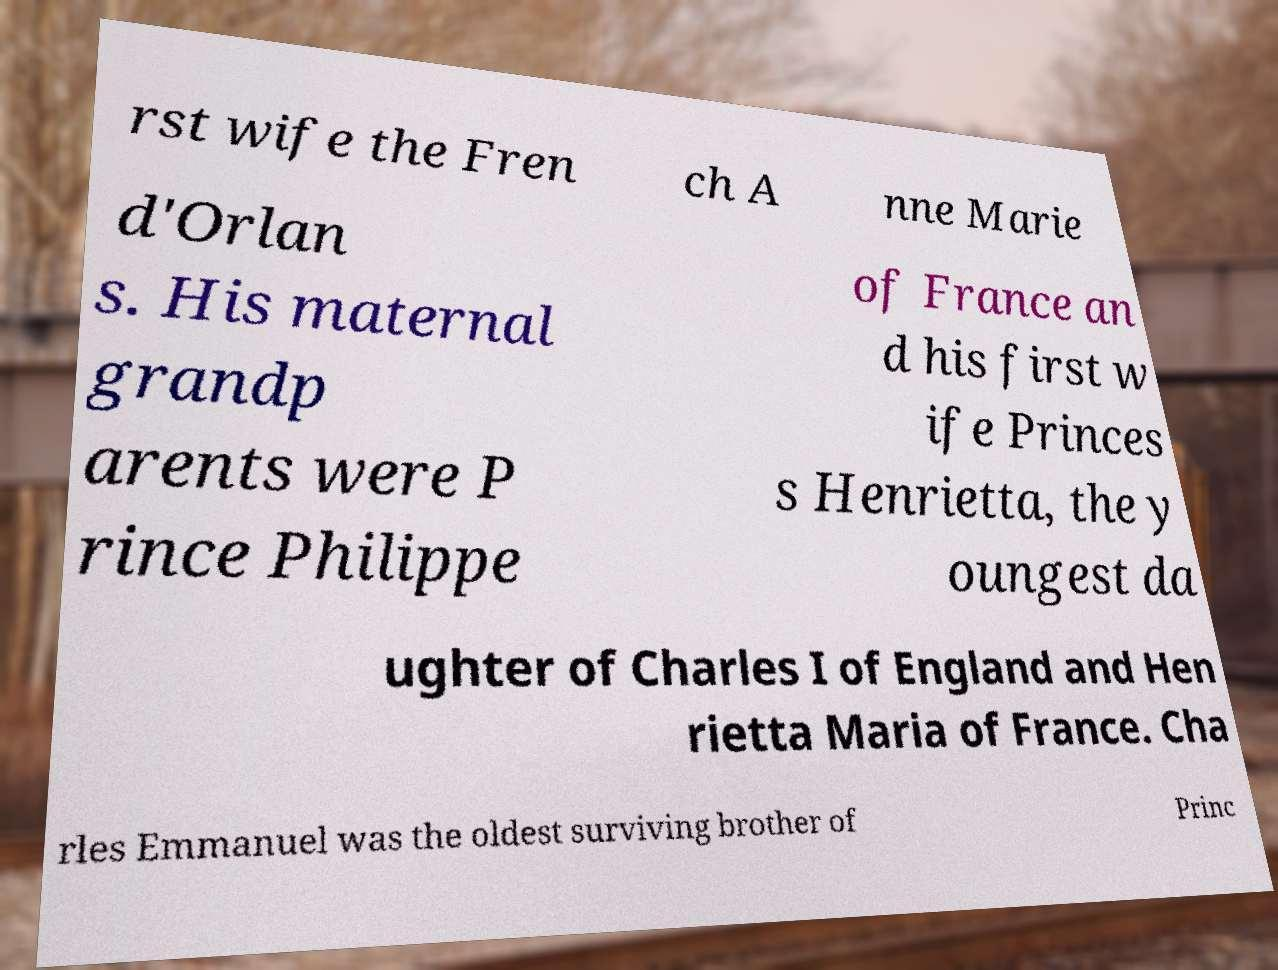Can you accurately transcribe the text from the provided image for me? rst wife the Fren ch A nne Marie d'Orlan s. His maternal grandp arents were P rince Philippe of France an d his first w ife Princes s Henrietta, the y oungest da ughter of Charles I of England and Hen rietta Maria of France. Cha rles Emmanuel was the oldest surviving brother of Princ 